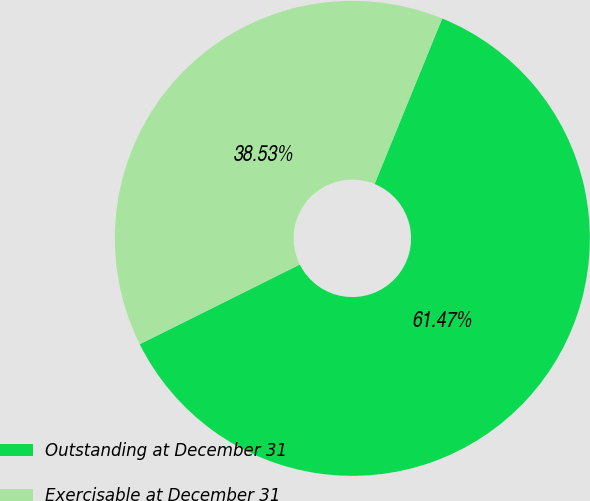Convert chart. <chart><loc_0><loc_0><loc_500><loc_500><pie_chart><fcel>Outstanding at December 31<fcel>Exercisable at December 31<nl><fcel>61.47%<fcel>38.53%<nl></chart> 